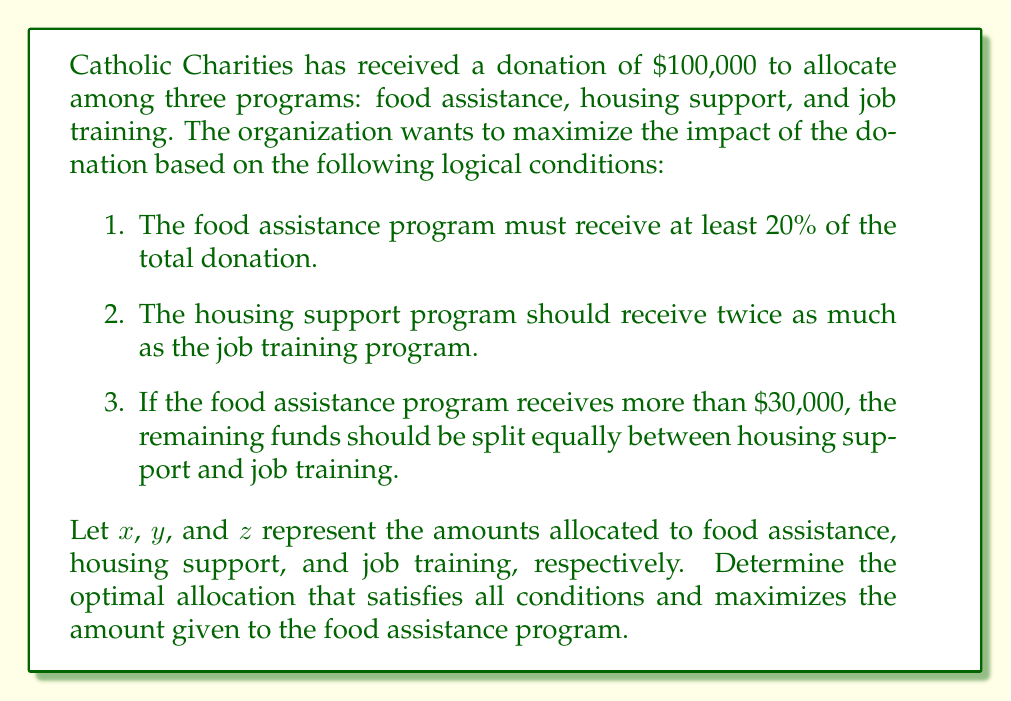Help me with this question. Let's approach this problem step-by-step using mathematical logic:

1. We start with the total donation: $x + y + z = 100,000$

2. From condition 1, we know that $x \geq 20,000$

3. From condition 2, we can express $y$ in terms of $z$: $y = 2z$

4. Substituting this into our total donation equation:
   $x + 2z + z = 100,000$
   $x + 3z = 100,000$

5. Now, we need to consider two cases based on condition 3:

   Case 1: If $x \leq 30,000$
   In this case, we want to maximize $x$ while satisfying all conditions. The maximum value for $x$ in this case would be $30,000$.
   
   $30,000 + 3z = 100,000$
   $3z = 70,000$
   $z = 23,333.33$
   $y = 2z = 46,666.67$

   Case 2: If $x > 30,000$
   In this case, the remaining funds should be split equally between $y$ and $z$.
   
   $y = z = \frac{100,000 - x}{2}$

   But we also know that $y = 2z$, which means this case cannot satisfy all conditions simultaneously.

6. Therefore, the optimal solution that maximizes $x$ while satisfying all conditions is:
   $x = 30,000$
   $y = 46,666.67$
   $z = 23,333.33$

This allocation gives the maximum possible amount to food assistance while still meeting all the logical conditions set by Catholic Charities.
Answer: The optimal allocation is:
Food Assistance (x): $30,000
Housing Support (y): $46,666.67
Job Training (z): $23,333.33 